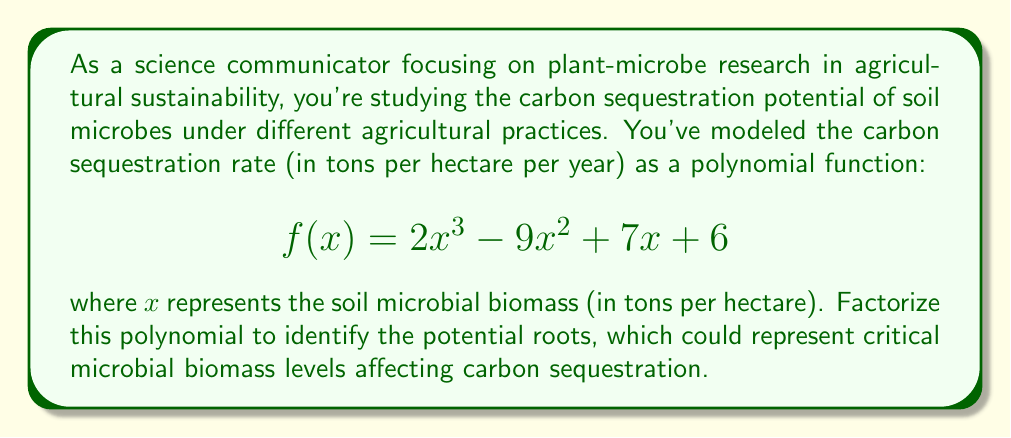What is the answer to this math problem? To factorize the polynomial $f(x) = 2x^3 - 9x^2 + 7x + 6$, we'll follow these steps:

1) First, let's check if there are any common factors. In this case, there are none.

2) Next, we'll use the rational root theorem to find potential roots. The potential rational roots are the factors of the constant term (6) divided by the factors of the leading coefficient (2). These are: $\pm 1, \pm 2, \pm 3, \pm 6, \pm \frac{1}{2}, \pm \frac{3}{2}$.

3) Testing these values, we find that $x = -1$ is a root of the polynomial.

4) We can factor out $(x+1)$:
   $f(x) = (x+1)(2x^2 - 11x + 6)$

5) Now we need to factor the quadratic $2x^2 - 11x + 6$. We can do this by finding two numbers that multiply to give $2 \times 6 = 12$ and add up to $-11$. These numbers are $-9$ and $-2$.

6) So we can rewrite the quadratic as:
   $2x^2 - 11x + 6 = 2x^2 - 9x - 2x + 6 = x(2x - 9) - 2(x - 3) = (2x - 3)(x - 2)$

7) Putting it all together:
   $f(x) = (x+1)(2x - 3)(x - 2)$

This factorization reveals that the critical microbial biomass levels are at 1, 1.5, and 2 tons per hectare, which could represent important thresholds in the carbon sequestration process.
Answer: $f(x) = (x+1)(2x - 3)(x - 2)$ 